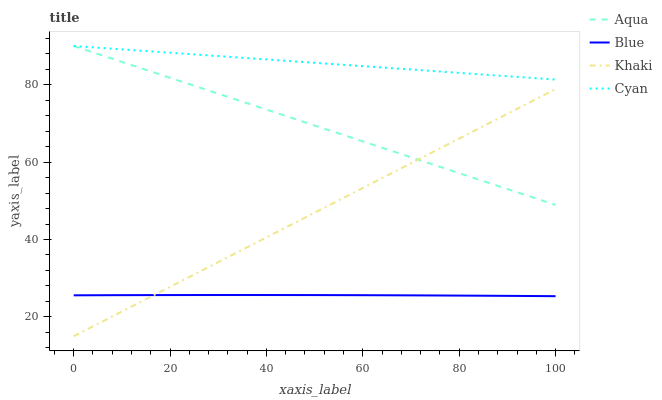Does Khaki have the minimum area under the curve?
Answer yes or no. No. Does Khaki have the maximum area under the curve?
Answer yes or no. No. Is Cyan the smoothest?
Answer yes or no. No. Is Cyan the roughest?
Answer yes or no. No. Does Cyan have the lowest value?
Answer yes or no. No. Does Khaki have the highest value?
Answer yes or no. No. Is Blue less than Aqua?
Answer yes or no. Yes. Is Cyan greater than Blue?
Answer yes or no. Yes. Does Blue intersect Aqua?
Answer yes or no. No. 